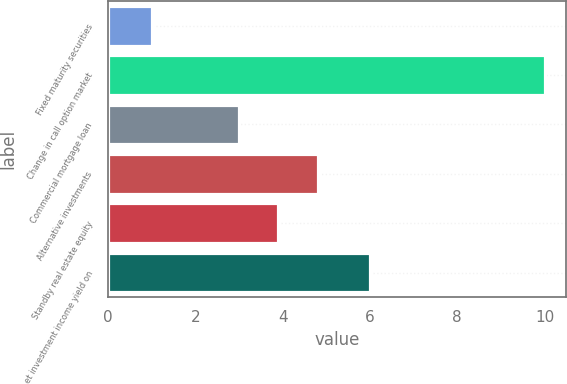<chart> <loc_0><loc_0><loc_500><loc_500><bar_chart><fcel>Fixed maturity securities<fcel>Change in call option market<fcel>Commercial mortgage loan<fcel>Alternative investments<fcel>Standby real estate equity<fcel>et investment income yield on<nl><fcel>1<fcel>10<fcel>3<fcel>4.8<fcel>3.9<fcel>6<nl></chart> 